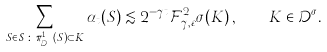<formula> <loc_0><loc_0><loc_500><loc_500>\sum _ { S \in \mathcal { S } \, \colon \, \pi _ { \mathcal { D } ^ { \sigma } } ^ { 1 } \left ( S \right ) \subset K } \alpha _ { t } ( S ) \lesssim 2 ^ { - \gamma t } \mathcal { F } _ { \gamma , \varepsilon } ^ { 2 } \sigma ( K ) \, , \quad K \in \mathcal { D } ^ { \sigma } .</formula> 